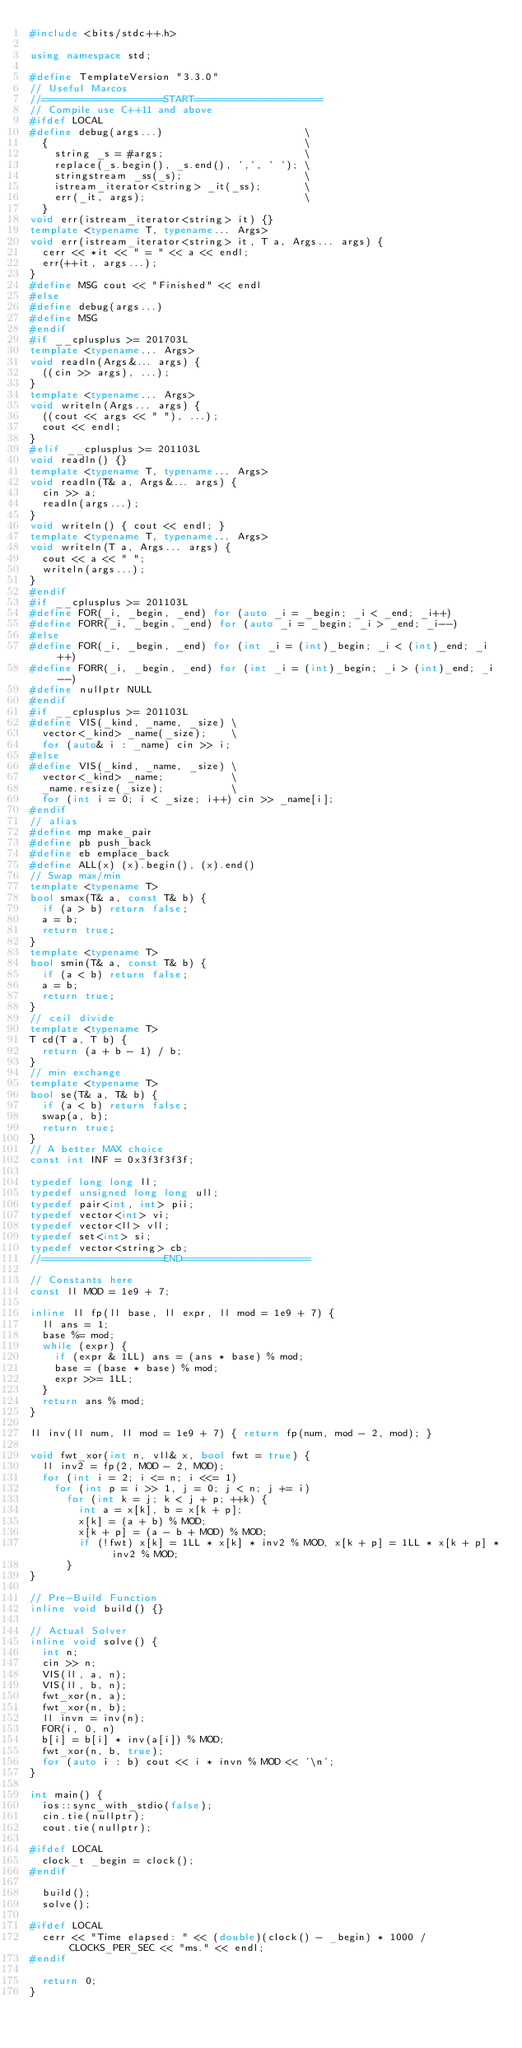<code> <loc_0><loc_0><loc_500><loc_500><_C++_>#include <bits/stdc++.h>

using namespace std;

#define TemplateVersion "3.3.0"
// Useful Marcos
//====================START=====================
// Compile use C++11 and above
#ifdef LOCAL
#define debug(args...)                       \
  {                                          \
    string _s = #args;                       \
    replace(_s.begin(), _s.end(), ',', ' '); \
    stringstream _ss(_s);                    \
    istream_iterator<string> _it(_ss);       \
    err(_it, args);                          \
  }
void err(istream_iterator<string> it) {}
template <typename T, typename... Args>
void err(istream_iterator<string> it, T a, Args... args) {
  cerr << *it << " = " << a << endl;
  err(++it, args...);
}
#define MSG cout << "Finished" << endl
#else
#define debug(args...)
#define MSG
#endif
#if __cplusplus >= 201703L
template <typename... Args>
void readln(Args&... args) {
  ((cin >> args), ...);
}
template <typename... Args>
void writeln(Args... args) {
  ((cout << args << " "), ...);
  cout << endl;
}
#elif __cplusplus >= 201103L
void readln() {}
template <typename T, typename... Args>
void readln(T& a, Args&... args) {
  cin >> a;
  readln(args...);
}
void writeln() { cout << endl; }
template <typename T, typename... Args>
void writeln(T a, Args... args) {
  cout << a << " ";
  writeln(args...);
}
#endif
#if __cplusplus >= 201103L
#define FOR(_i, _begin, _end) for (auto _i = _begin; _i < _end; _i++)
#define FORR(_i, _begin, _end) for (auto _i = _begin; _i > _end; _i--)
#else
#define FOR(_i, _begin, _end) for (int _i = (int)_begin; _i < (int)_end; _i++)
#define FORR(_i, _begin, _end) for (int _i = (int)_begin; _i > (int)_end; _i--)
#define nullptr NULL
#endif
#if __cplusplus >= 201103L
#define VIS(_kind, _name, _size) \
  vector<_kind> _name(_size);    \
  for (auto& i : _name) cin >> i;
#else
#define VIS(_kind, _name, _size) \
  vector<_kind> _name;           \
  _name.resize(_size);           \
  for (int i = 0; i < _size; i++) cin >> _name[i];
#endif
// alias
#define mp make_pair
#define pb push_back
#define eb emplace_back
#define ALL(x) (x).begin(), (x).end()
// Swap max/min
template <typename T>
bool smax(T& a, const T& b) {
  if (a > b) return false;
  a = b;
  return true;
}
template <typename T>
bool smin(T& a, const T& b) {
  if (a < b) return false;
  a = b;
  return true;
}
// ceil divide
template <typename T>
T cd(T a, T b) {
  return (a + b - 1) / b;
}
// min exchange
template <typename T>
bool se(T& a, T& b) {
  if (a < b) return false;
  swap(a, b);
  return true;
}
// A better MAX choice
const int INF = 0x3f3f3f3f;

typedef long long ll;
typedef unsigned long long ull;
typedef pair<int, int> pii;
typedef vector<int> vi;
typedef vector<ll> vll;
typedef set<int> si;
typedef vector<string> cb;
//====================END=====================

// Constants here
const ll MOD = 1e9 + 7;

inline ll fp(ll base, ll expr, ll mod = 1e9 + 7) {
  ll ans = 1;
  base %= mod;
  while (expr) {
    if (expr & 1LL) ans = (ans * base) % mod;
    base = (base * base) % mod;
    expr >>= 1LL;
  }
  return ans % mod;
}

ll inv(ll num, ll mod = 1e9 + 7) { return fp(num, mod - 2, mod); }

void fwt_xor(int n, vll& x, bool fwt = true) {
  ll inv2 = fp(2, MOD - 2, MOD);
  for (int i = 2; i <= n; i <<= 1)
    for (int p = i >> 1, j = 0; j < n; j += i)
      for (int k = j; k < j + p; ++k) {
        int a = x[k], b = x[k + p];
        x[k] = (a + b) % MOD;
        x[k + p] = (a - b + MOD) % MOD;
        if (!fwt) x[k] = 1LL * x[k] * inv2 % MOD, x[k + p] = 1LL * x[k + p] * inv2 % MOD;
      }
}

// Pre-Build Function
inline void build() {}

// Actual Solver
inline void solve() {
  int n;
  cin >> n;
  VIS(ll, a, n);
  VIS(ll, b, n);
  fwt_xor(n, a);
  fwt_xor(n, b);
  ll invn = inv(n);
  FOR(i, 0, n)
  b[i] = b[i] * inv(a[i]) % MOD;
  fwt_xor(n, b, true);
  for (auto i : b) cout << i * invn % MOD << '\n';
}

int main() {
  ios::sync_with_stdio(false);
  cin.tie(nullptr);
  cout.tie(nullptr);

#ifdef LOCAL
  clock_t _begin = clock();
#endif

  build();
  solve();

#ifdef LOCAL
  cerr << "Time elapsed: " << (double)(clock() - _begin) * 1000 / CLOCKS_PER_SEC << "ms." << endl;
#endif

  return 0;
}</code> 